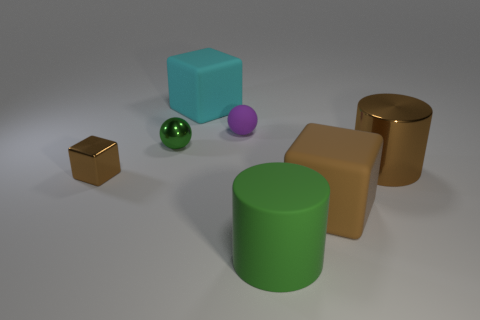Subtract all purple cylinders. How many brown blocks are left? 2 Subtract all big cyan rubber cubes. How many cubes are left? 2 Add 3 small metallic spheres. How many objects exist? 10 Subtract all yellow blocks. Subtract all red cylinders. How many blocks are left? 3 Subtract all blocks. How many objects are left? 4 Subtract 1 green cylinders. How many objects are left? 6 Subtract all brown metallic cubes. Subtract all brown shiny blocks. How many objects are left? 5 Add 1 purple spheres. How many purple spheres are left? 2 Add 5 tiny brown cubes. How many tiny brown cubes exist? 6 